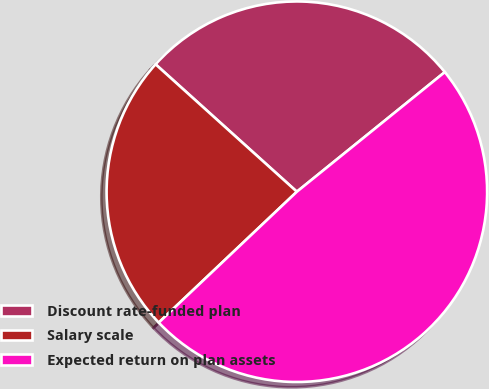<chart> <loc_0><loc_0><loc_500><loc_500><pie_chart><fcel>Discount rate-funded plan<fcel>Salary scale<fcel>Expected return on plan assets<nl><fcel>27.5%<fcel>23.75%<fcel>48.75%<nl></chart> 